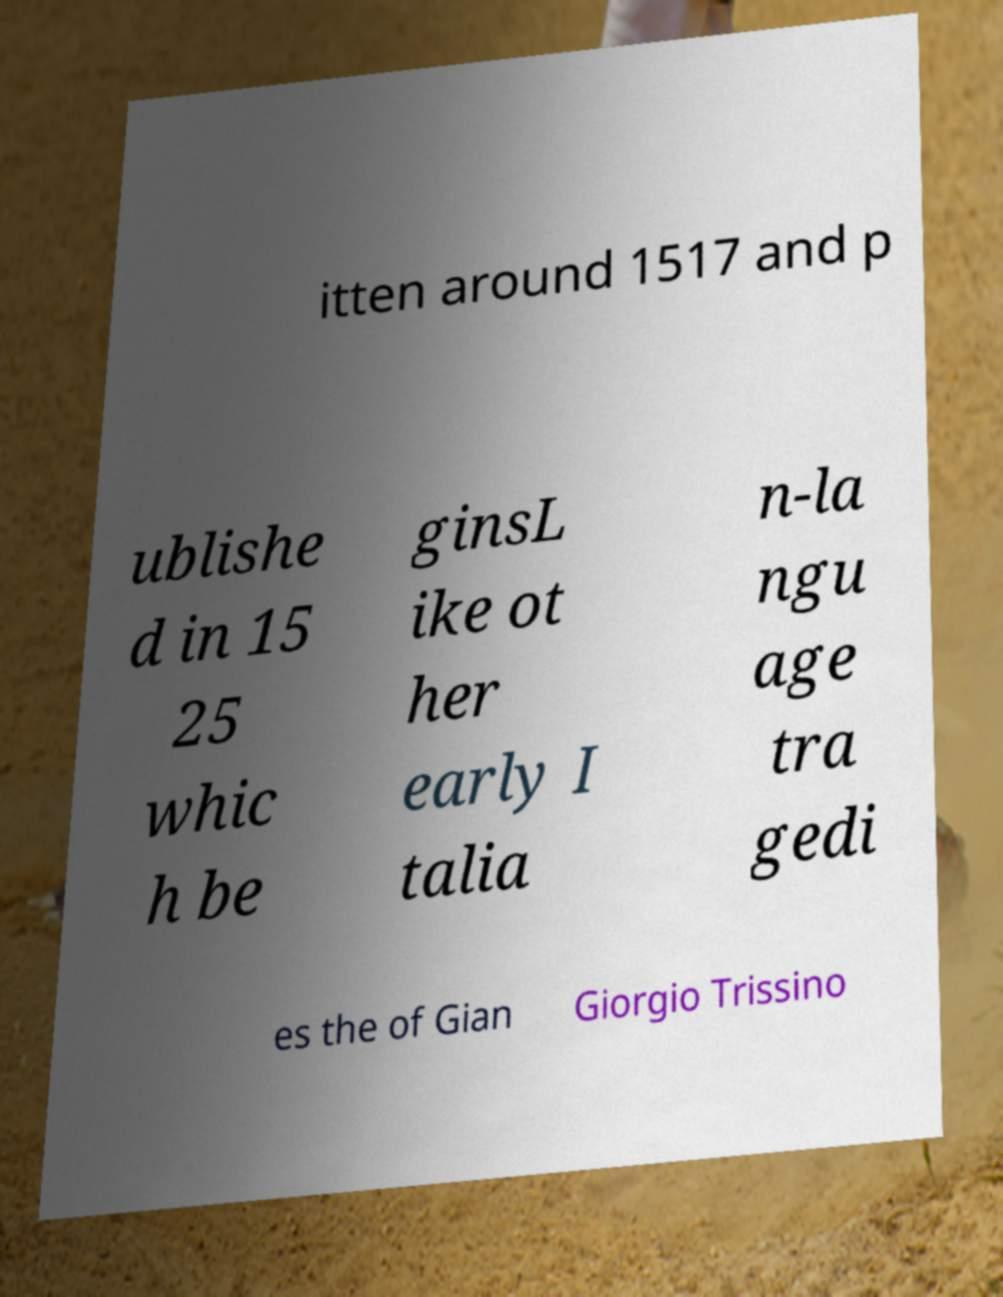Please identify and transcribe the text found in this image. itten around 1517 and p ublishe d in 15 25 whic h be ginsL ike ot her early I talia n-la ngu age tra gedi es the of Gian Giorgio Trissino 